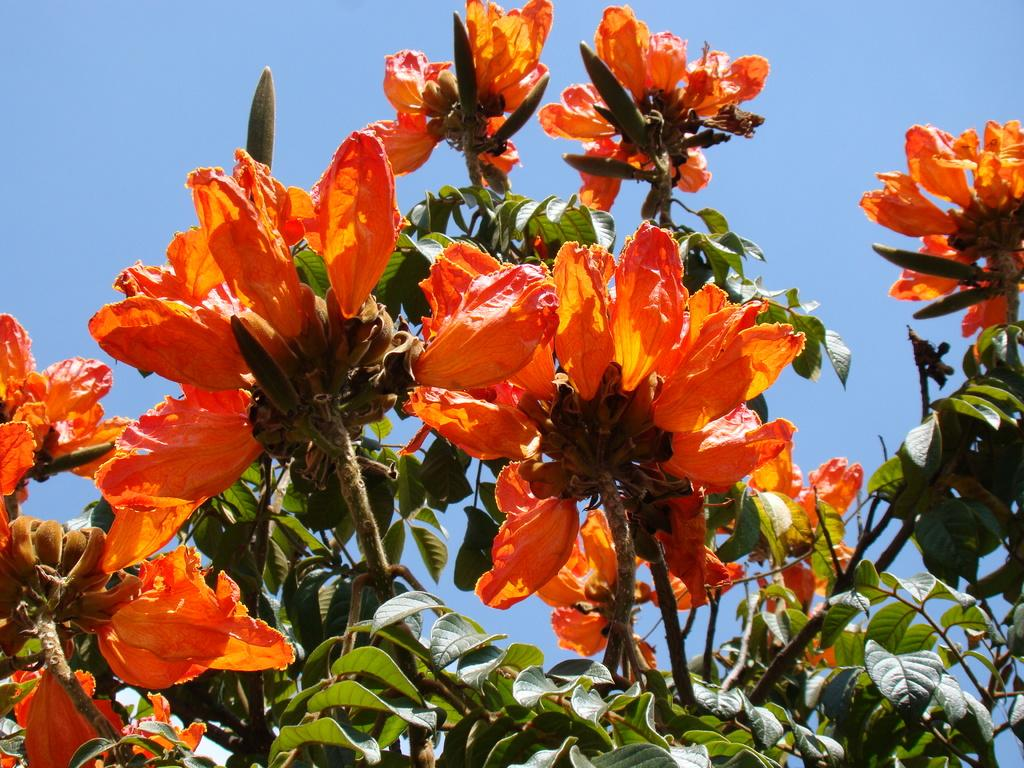What type of vegetation can be seen on the tree in the image? There are flowers on the tree in the image. How many stamps are attached to the flowers on the tree in the image? There are no stamps present on the flowers or the tree in the image. 